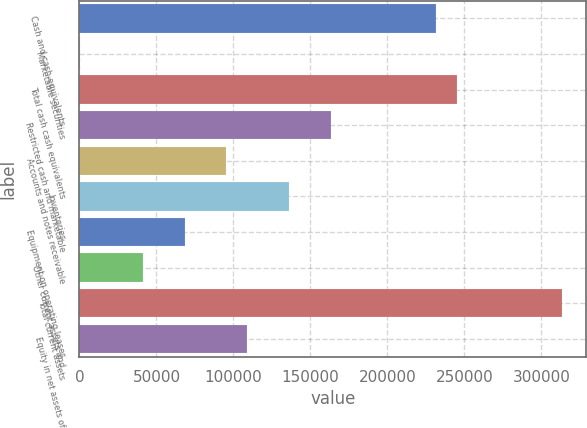Convert chart. <chart><loc_0><loc_0><loc_500><loc_500><bar_chart><fcel>Cash and cash equivalents<fcel>Marketable securities<fcel>Total cash cash equivalents<fcel>Restricted cash and marketable<fcel>Accounts and notes receivable<fcel>Inventories<fcel>Equipment on operating leases<fcel>Other current assets and<fcel>Total current assets<fcel>Equity in net assets of<nl><fcel>231608<fcel>134<fcel>245224<fcel>163527<fcel>95446.7<fcel>136295<fcel>68214.5<fcel>40982.3<fcel>313304<fcel>109063<nl></chart> 